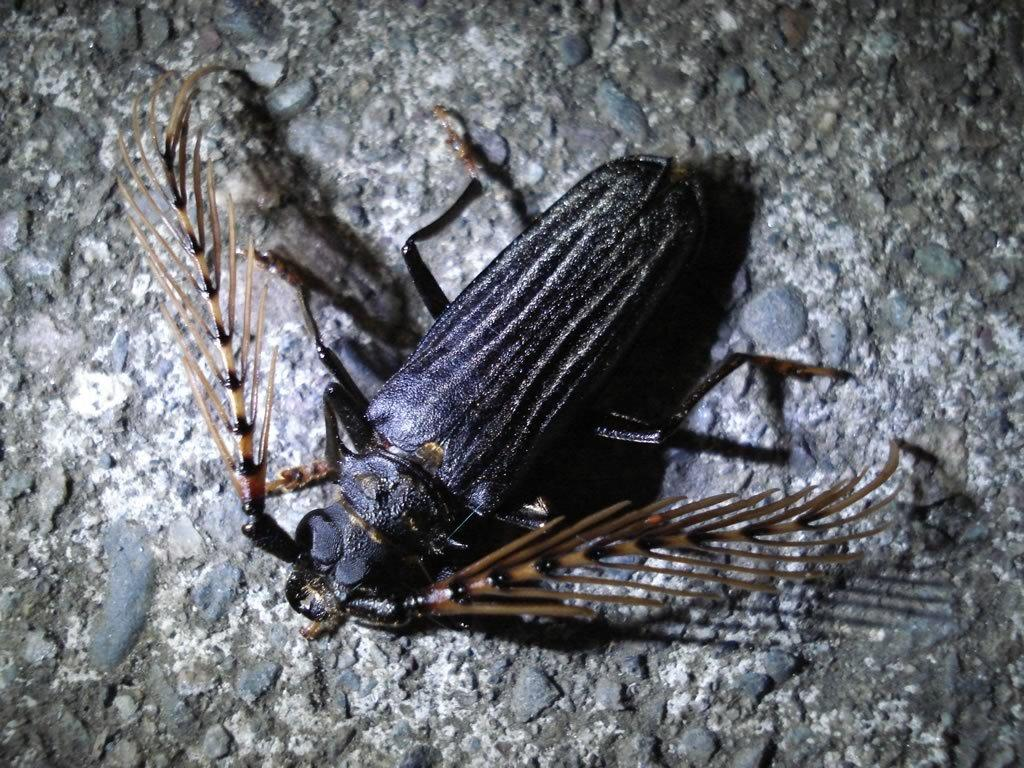How many arrows are in the kitty's quiver in the image? There is no kitty or quiver present in the image, as no specific facts were provided. How many arrows are in the kitty's quiver in the image? There is no kitty or quiver present in the image, as no specific facts were provided. 